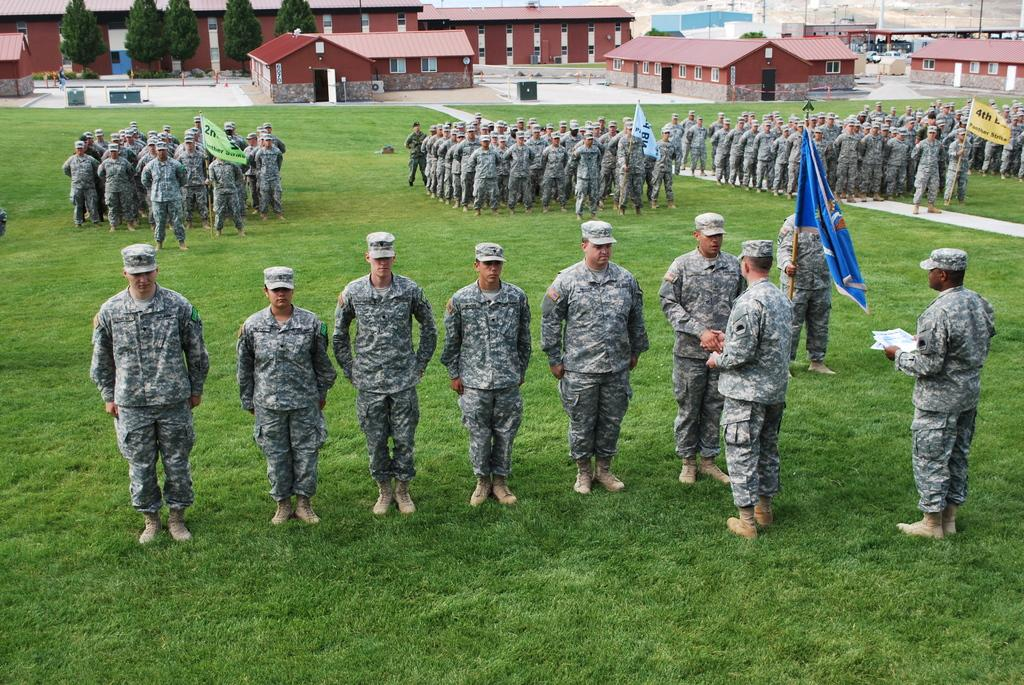How many people are in the image? There is a group of people in the image, but the exact number is not specified. What are the people doing in the image? The people are on the ground and holding flags. What type of surface are the people standing on? There is grass in the image, so the people are standing on grass. What can be seen in the background of the image? There are houses, plants, and trees in the background of the image. What type of silk fabric is draped over the trees in the image? There is no silk fabric present in the image; the trees are surrounded by grass and other plants. 